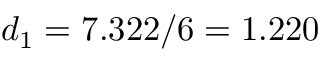<formula> <loc_0><loc_0><loc_500><loc_500>d _ { 1 } = 7 . 3 2 2 / 6 = 1 . 2 2 0</formula> 